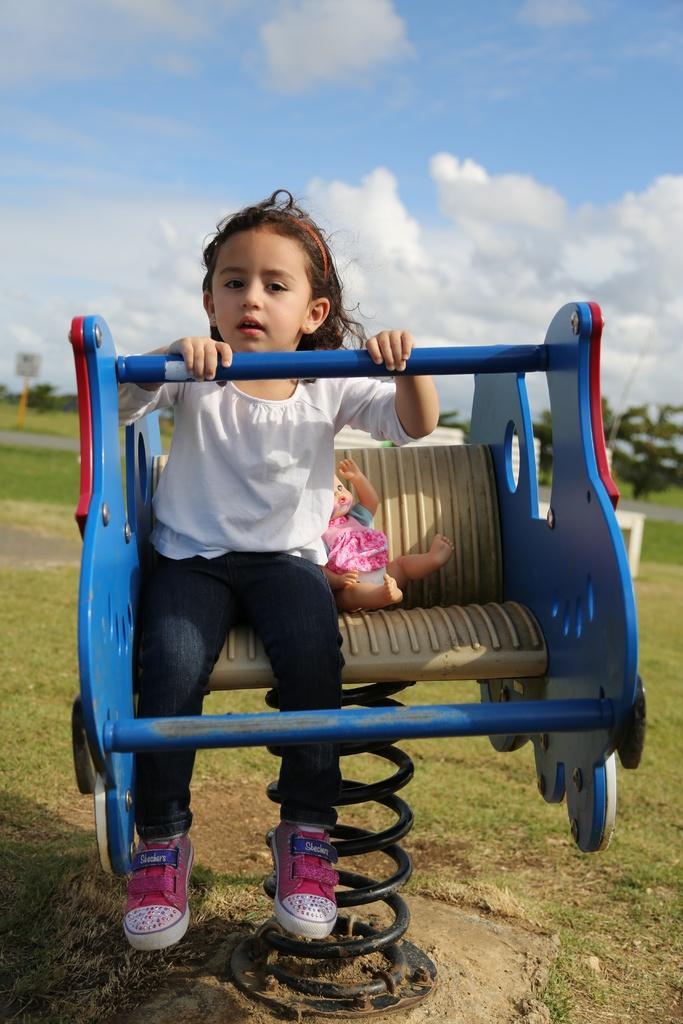Could you give a brief overview of what you see in this image? In the image I can see a girl is sitting on an object. The girl is wearing white color top, jeans and shoes. In the background I can see trees, the grass and the sky. 